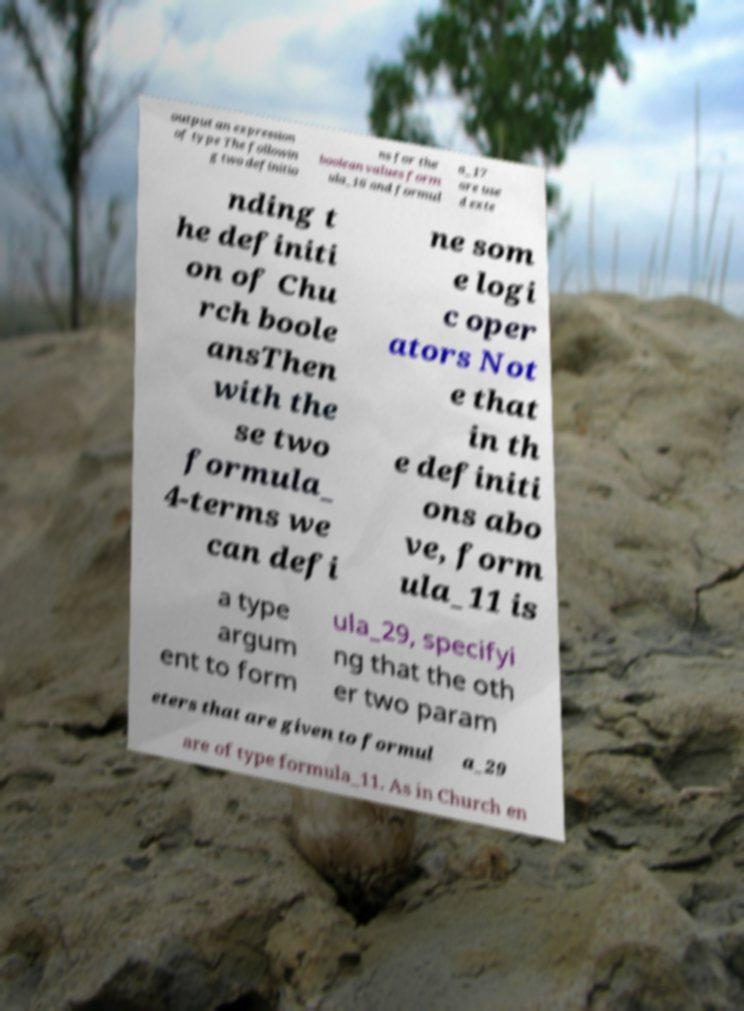For documentation purposes, I need the text within this image transcribed. Could you provide that? output an expression of type The followin g two definitio ns for the boolean values form ula_16 and formul a_17 are use d exte nding t he definiti on of Chu rch boole ansThen with the se two formula_ 4-terms we can defi ne som e logi c oper ators Not e that in th e definiti ons abo ve, form ula_11 is a type argum ent to form ula_29, specifyi ng that the oth er two param eters that are given to formul a_29 are of type formula_11. As in Church en 